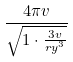Convert formula to latex. <formula><loc_0><loc_0><loc_500><loc_500>\frac { 4 \pi v } { \sqrt { 1 \cdot \frac { 3 v } { r y ^ { 3 } } } }</formula> 